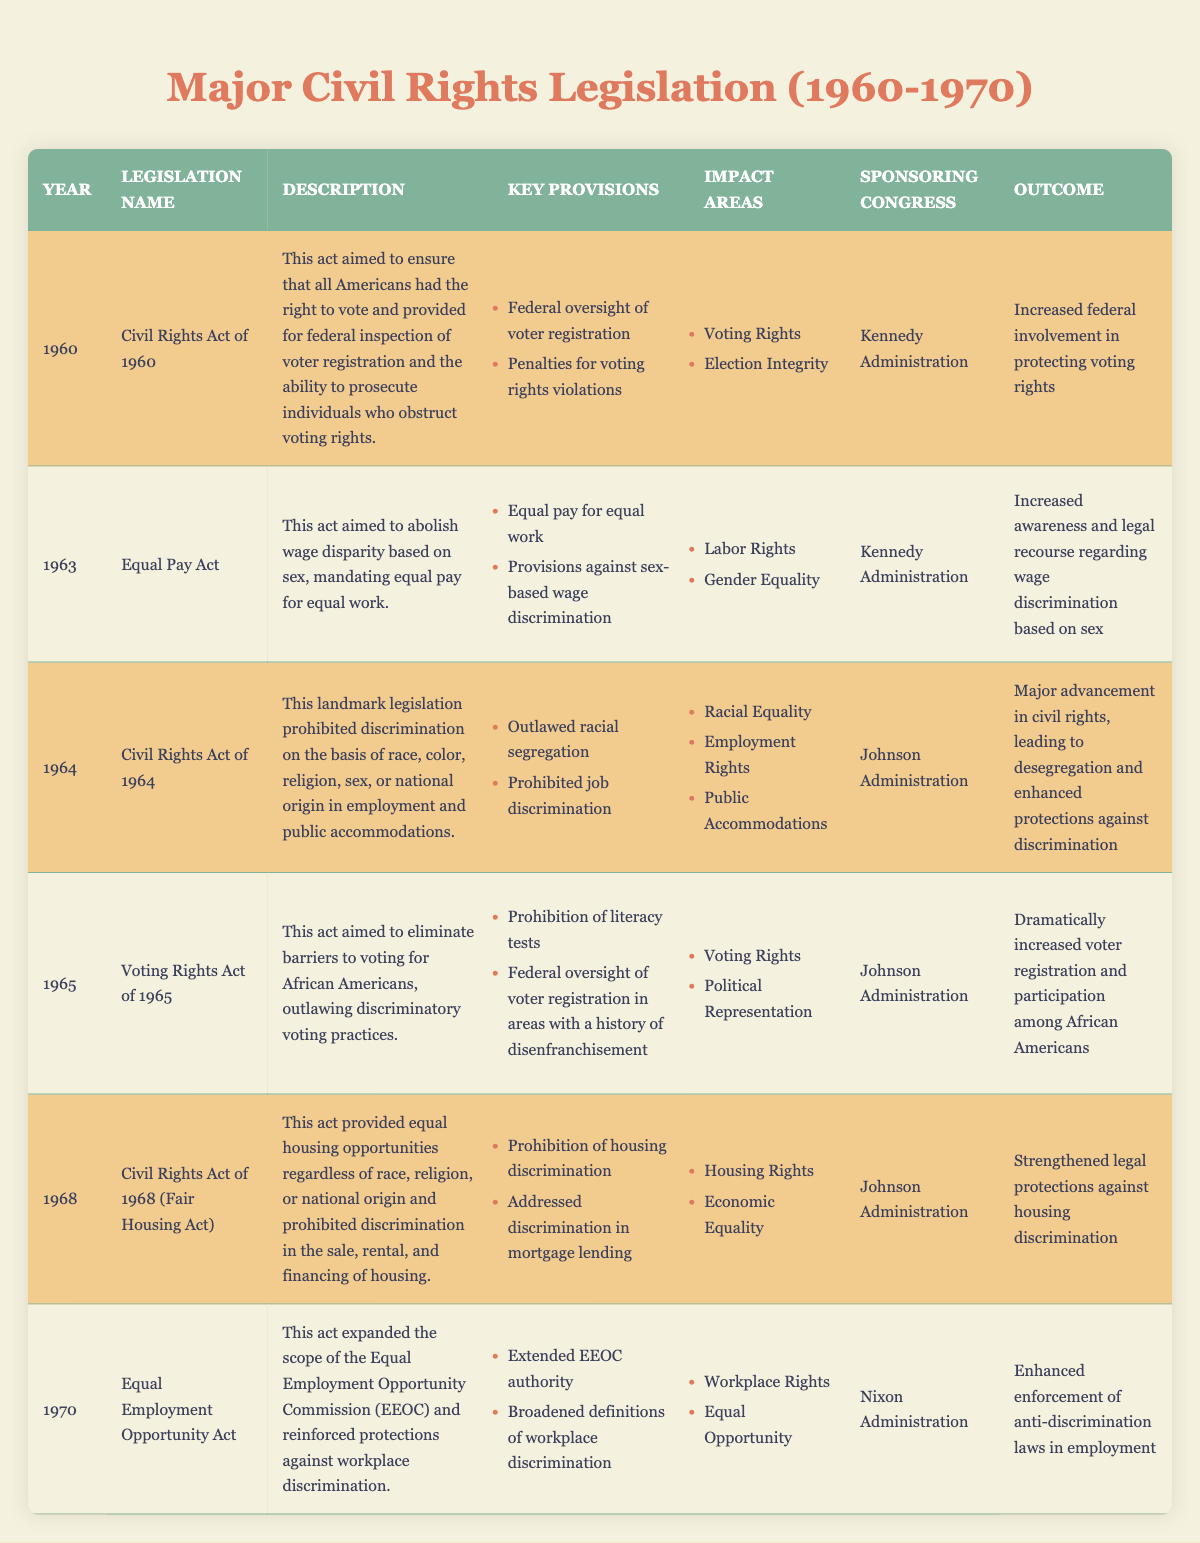What year was the Civil Rights Act of 1968 enacted? The table lists the legislation along with its corresponding years. By looking at the row for "Civil Rights Act of 1968", we can see that it was enacted in 1968.
Answer: 1968 Which administration sponsored the Voting Rights Act of 1965? The table indicates that the "Johnson Administration" sponsored the "Voting Rights Act of 1965".
Answer: Johnson Administration What was a key provision of the Equal Pay Act of 1963? The "Equal Pay Act" row in the table notes that one of its key provisions is "Equal pay for equal work".
Answer: Equal pay for equal work What was the outcome of the Civil Rights Act of 1964? The table shows that the outcome of the "Civil Rights Act of 1964" was "Major advancement in civil rights, leading to desegregation and enhanced protections against discrimination".
Answer: Major advancement in civil rights How many pieces of legislation were passed in the 1960s? Counting the entries from 1960 to 1969 in the table, we find five pieces of legislation: 1960, 1963, 1964, 1965, and 1968.
Answer: 5 Did the Equal Employment Opportunity Act of 1970 expand the authority of the EEOC? The table states that the Equal Employment Opportunity Act of 1970 "extended EEOC authority", which indicates that it did indeed expand the authority of the EEOC.
Answer: Yes What are the impact areas of the Civil Rights Act of 1964? In the row for the "Civil Rights Act of 1964", the impact areas are listed as "Racial Equality", "Employment Rights", and "Public Accommodations".
Answer: Racial Equality, Employment Rights, Public Accommodations Compare the outcomes of the civil rights legislation in the 1960s to that of the Equal Employment Opportunity Act of 1970. The outcomes listed show that legislation in the 1960s primarily focused on desegregation and increased voting rights for African Americans, while the 1970 Act enhanced anti-discrimination laws in employment, focusing on workplace rights. Hence, while the earlier acts shaped social integration, the 1970 Act reinforced workplace equality.
Answer: Previous acts focused on voting and social integration; 1970 Act focused on workplace equality What was the main focus of the Voting Rights Act of 1965? The table describes the focus of the Voting Rights Act of 1965 as eliminating barriers to voting for African Americans and outlawing discriminatory voting practices.
Answer: Elimination of voting barriers for African Americans Were any of the acts in the table passed during the Nixon Administration? The only act listed that was passed during the Nixon Administration is the "Equal Employment Opportunity Act of 1970", which confirms there was at least one act under Nixon.
Answer: Yes 